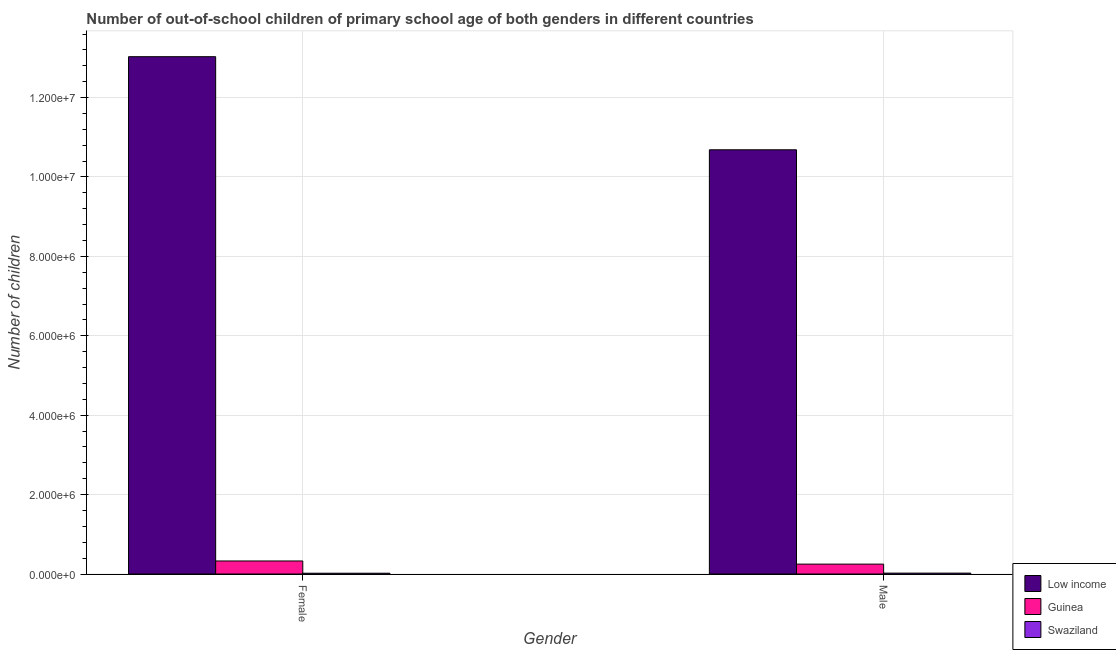How many different coloured bars are there?
Offer a very short reply. 3. How many groups of bars are there?
Your response must be concise. 2. How many bars are there on the 2nd tick from the left?
Provide a short and direct response. 3. How many bars are there on the 2nd tick from the right?
Keep it short and to the point. 3. What is the number of male out-of-school students in Swaziland?
Give a very brief answer. 2.24e+04. Across all countries, what is the maximum number of male out-of-school students?
Provide a short and direct response. 1.07e+07. Across all countries, what is the minimum number of male out-of-school students?
Ensure brevity in your answer.  2.24e+04. In which country was the number of male out-of-school students minimum?
Give a very brief answer. Swaziland. What is the total number of female out-of-school students in the graph?
Your answer should be very brief. 1.34e+07. What is the difference between the number of male out-of-school students in Swaziland and that in Guinea?
Your answer should be very brief. -2.27e+05. What is the difference between the number of female out-of-school students in Swaziland and the number of male out-of-school students in Guinea?
Your response must be concise. -2.30e+05. What is the average number of female out-of-school students per country?
Offer a terse response. 4.46e+06. What is the difference between the number of male out-of-school students and number of female out-of-school students in Guinea?
Offer a terse response. -7.92e+04. In how many countries, is the number of female out-of-school students greater than 12400000 ?
Make the answer very short. 1. What is the ratio of the number of female out-of-school students in Swaziland to that in Low income?
Provide a succinct answer. 0. Is the number of male out-of-school students in Swaziland less than that in Guinea?
Offer a terse response. Yes. In how many countries, is the number of male out-of-school students greater than the average number of male out-of-school students taken over all countries?
Offer a very short reply. 1. What does the 2nd bar from the left in Female represents?
Provide a short and direct response. Guinea. What does the 2nd bar from the right in Female represents?
Provide a succinct answer. Guinea. How many bars are there?
Make the answer very short. 6. Does the graph contain grids?
Provide a succinct answer. Yes. Where does the legend appear in the graph?
Offer a terse response. Bottom right. What is the title of the graph?
Your answer should be compact. Number of out-of-school children of primary school age of both genders in different countries. What is the label or title of the Y-axis?
Ensure brevity in your answer.  Number of children. What is the Number of children of Low income in Female?
Give a very brief answer. 1.30e+07. What is the Number of children in Guinea in Female?
Your answer should be very brief. 3.28e+05. What is the Number of children in Swaziland in Female?
Offer a terse response. 1.94e+04. What is the Number of children in Low income in Male?
Offer a terse response. 1.07e+07. What is the Number of children of Guinea in Male?
Provide a short and direct response. 2.49e+05. What is the Number of children in Swaziland in Male?
Your answer should be very brief. 2.24e+04. Across all Gender, what is the maximum Number of children in Low income?
Your response must be concise. 1.30e+07. Across all Gender, what is the maximum Number of children of Guinea?
Offer a terse response. 3.28e+05. Across all Gender, what is the maximum Number of children in Swaziland?
Ensure brevity in your answer.  2.24e+04. Across all Gender, what is the minimum Number of children of Low income?
Your answer should be compact. 1.07e+07. Across all Gender, what is the minimum Number of children in Guinea?
Offer a terse response. 2.49e+05. Across all Gender, what is the minimum Number of children in Swaziland?
Provide a succinct answer. 1.94e+04. What is the total Number of children of Low income in the graph?
Provide a succinct answer. 2.37e+07. What is the total Number of children of Guinea in the graph?
Ensure brevity in your answer.  5.77e+05. What is the total Number of children in Swaziland in the graph?
Ensure brevity in your answer.  4.19e+04. What is the difference between the Number of children of Low income in Female and that in Male?
Make the answer very short. 2.35e+06. What is the difference between the Number of children in Guinea in Female and that in Male?
Offer a very short reply. 7.92e+04. What is the difference between the Number of children in Swaziland in Female and that in Male?
Your answer should be compact. -3010. What is the difference between the Number of children in Low income in Female and the Number of children in Guinea in Male?
Your response must be concise. 1.28e+07. What is the difference between the Number of children of Low income in Female and the Number of children of Swaziland in Male?
Give a very brief answer. 1.30e+07. What is the difference between the Number of children of Guinea in Female and the Number of children of Swaziland in Male?
Give a very brief answer. 3.06e+05. What is the average Number of children in Low income per Gender?
Ensure brevity in your answer.  1.19e+07. What is the average Number of children of Guinea per Gender?
Make the answer very short. 2.89e+05. What is the average Number of children in Swaziland per Gender?
Ensure brevity in your answer.  2.09e+04. What is the difference between the Number of children in Low income and Number of children in Guinea in Female?
Provide a succinct answer. 1.27e+07. What is the difference between the Number of children in Low income and Number of children in Swaziland in Female?
Offer a terse response. 1.30e+07. What is the difference between the Number of children in Guinea and Number of children in Swaziland in Female?
Offer a terse response. 3.09e+05. What is the difference between the Number of children of Low income and Number of children of Guinea in Male?
Make the answer very short. 1.04e+07. What is the difference between the Number of children in Low income and Number of children in Swaziland in Male?
Provide a succinct answer. 1.07e+07. What is the difference between the Number of children in Guinea and Number of children in Swaziland in Male?
Offer a very short reply. 2.27e+05. What is the ratio of the Number of children in Low income in Female to that in Male?
Keep it short and to the point. 1.22. What is the ratio of the Number of children of Guinea in Female to that in Male?
Your answer should be very brief. 1.32. What is the ratio of the Number of children of Swaziland in Female to that in Male?
Your answer should be compact. 0.87. What is the difference between the highest and the second highest Number of children in Low income?
Keep it short and to the point. 2.35e+06. What is the difference between the highest and the second highest Number of children in Guinea?
Make the answer very short. 7.92e+04. What is the difference between the highest and the second highest Number of children in Swaziland?
Your answer should be very brief. 3010. What is the difference between the highest and the lowest Number of children in Low income?
Your answer should be compact. 2.35e+06. What is the difference between the highest and the lowest Number of children of Guinea?
Your answer should be compact. 7.92e+04. What is the difference between the highest and the lowest Number of children of Swaziland?
Offer a very short reply. 3010. 